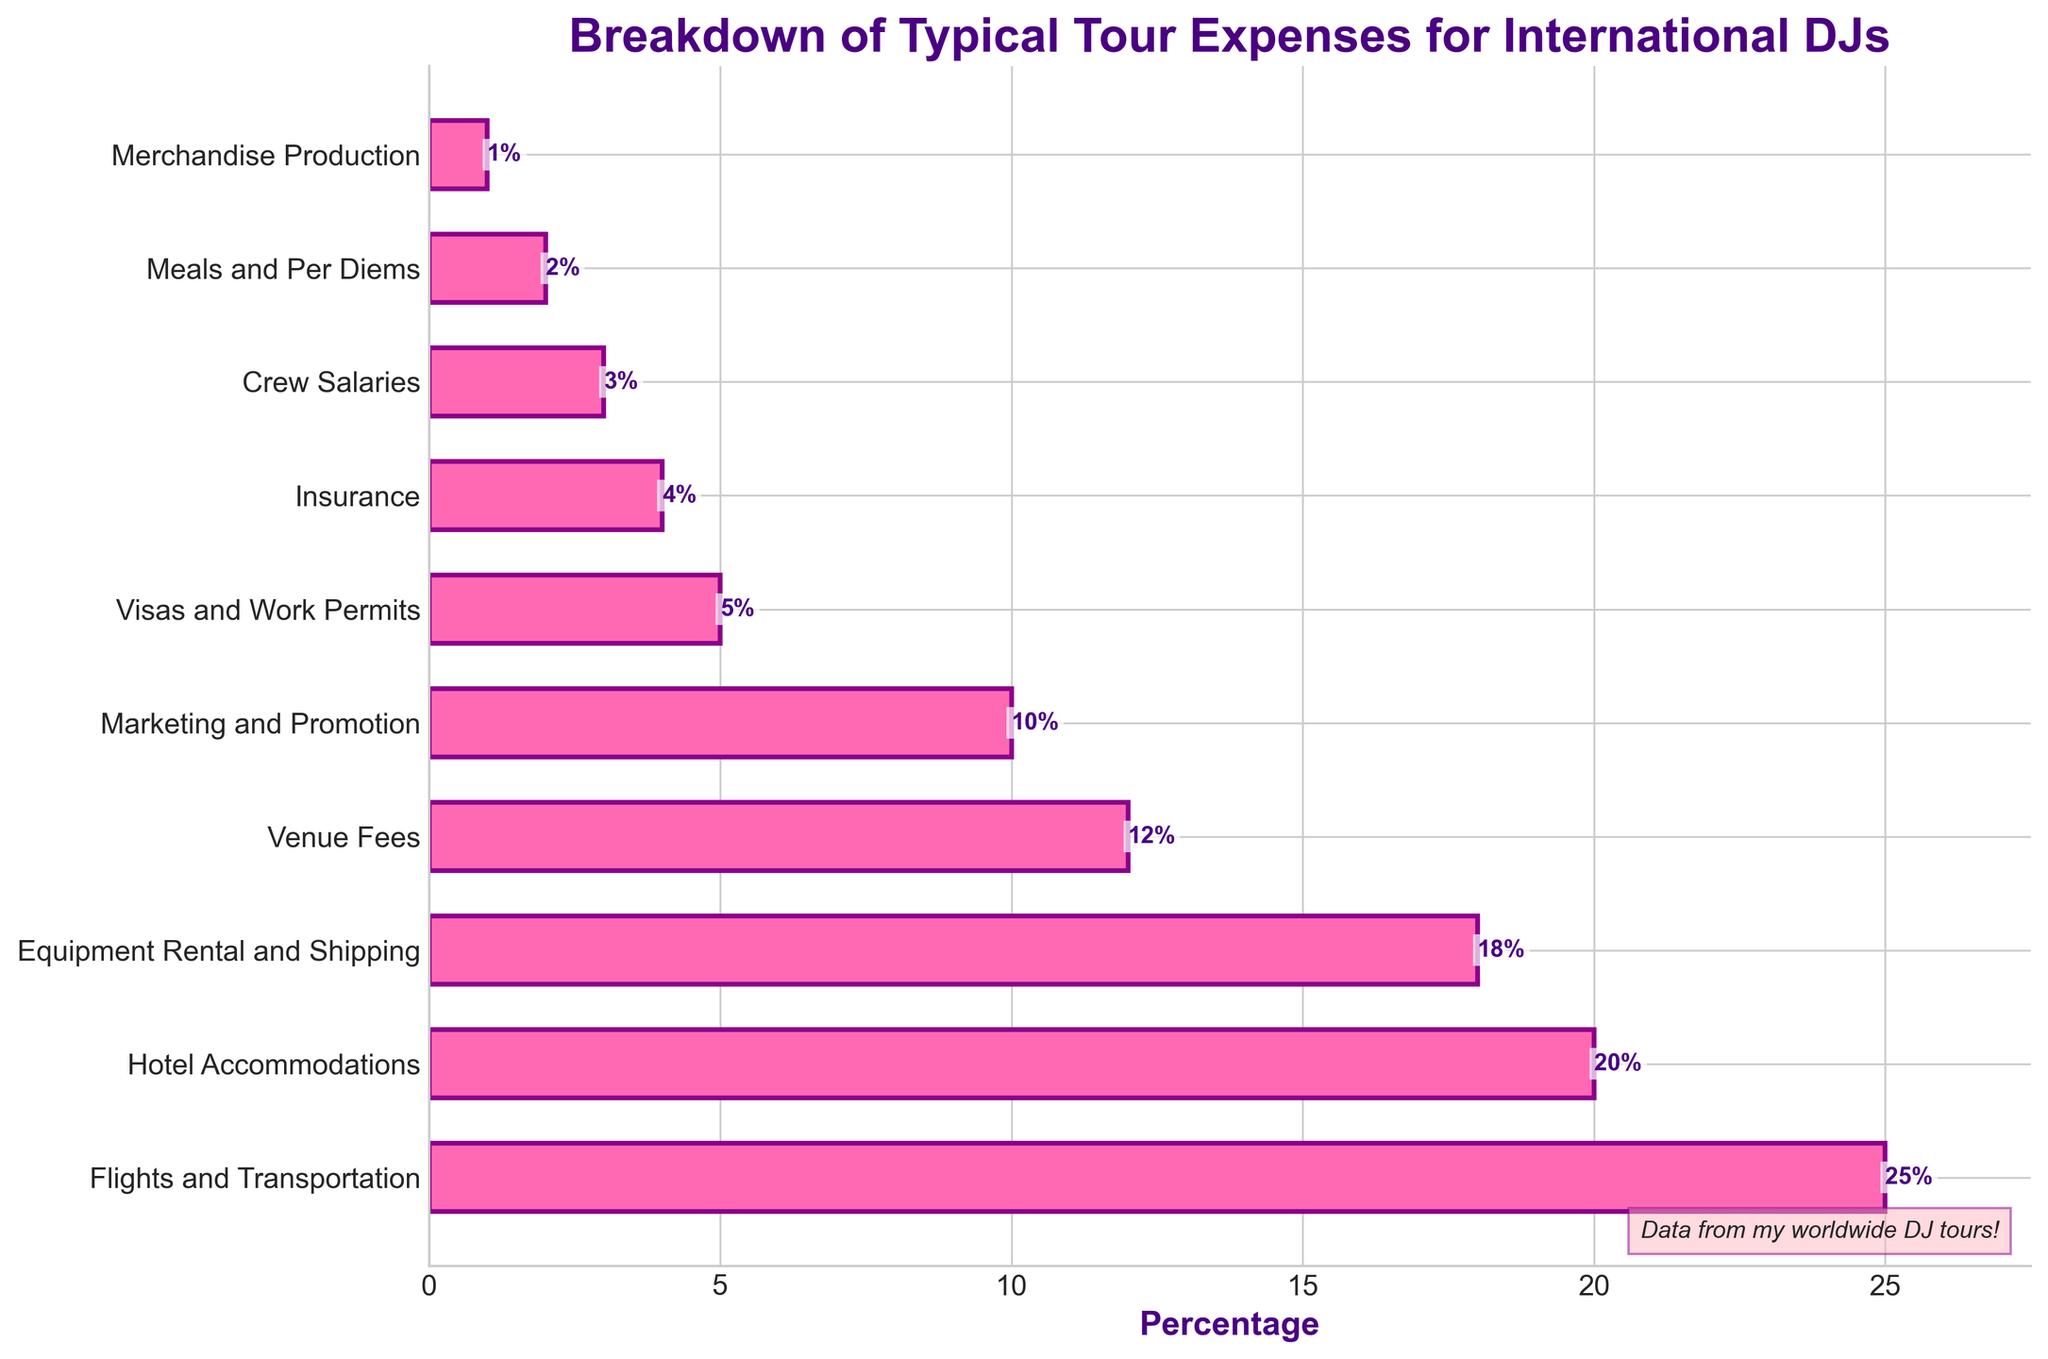Which category takes up the highest percentage of tour expenses? The highest bar in the bar chart represents the category "Flights and Transportation" with an expense percentage of 25%.
Answer: Flights and Transportation What is the combined percentage of expenses classified under "Hotel Accommodations" and "Marketing and Promotion"? The bar chart shows "Hotel Accommodations" with 20% and "Marketing and Promotion" with 10%. Adding these together: 20% + 10% = 30%.
Answer: 30% Which categories have less than a 5% share of the total expenses? According to the bar chart, "Insurance" (4%), "Crew Salaries" (3%), "Meals and Per Diems" (2%), and "Merchandise Production" (1%) all are below 5%.
Answer: Insurance, Crew Salaries, Meals and Per Diems, Merchandise Production How much higher is the percentage for "Equipment Rental and Shipping" compared to "Visas and Work Permits"? "Equipment Rental and Shipping" is at 18%, and "Visas and Work Permits" is at 5%. The difference is 18% - 5% = 13%.
Answer: 13% What percentage does "Venue Fees", "Crew Salaries", and "Meals and Per Diems" collectively represent? "Venue Fees" is 12%, "Crew Salaries" is 3%, and "Meals and Per Diems" is 2%. Summing these gives us 12% + 3% + 2% = 17%.
Answer: 17% Identify which category has a pink bar with a small length and its exact percentage value. The chart bars are pink for all categories. The category with the smallest bar is "Merchandise Production" at 1%.
Answer: Merchandise Production, 1% Which two categories together almost equal the expense percentage of "Flights and Transportation"? "Hotel Accommodations" (20%) and "Visas and Work Permits" (5%) together make 20% + 5% = 25%, which equals "Flights and Transportation".
Answer: Hotel Accommodations, Visas and Work Permits By what percentage is "Hotel Accommodations" less than "Flights and Transportation"? "Flights and Transportation" is 25%, and "Hotel Accommodations" is 20%. The difference is 25% - 20% = 5%.
Answer: 5% What is the average percentage of the categories with the lowest and highest expenses? The lowest is "Merchandise Production" at 1%, and the highest is "Flights and Transportation" at 25%. The average is (1% + 25%) / 2 = 13%.
Answer: 13% 